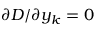Convert formula to latex. <formula><loc_0><loc_0><loc_500><loc_500>{ \partial D / \partial y _ { k } } = 0</formula> 